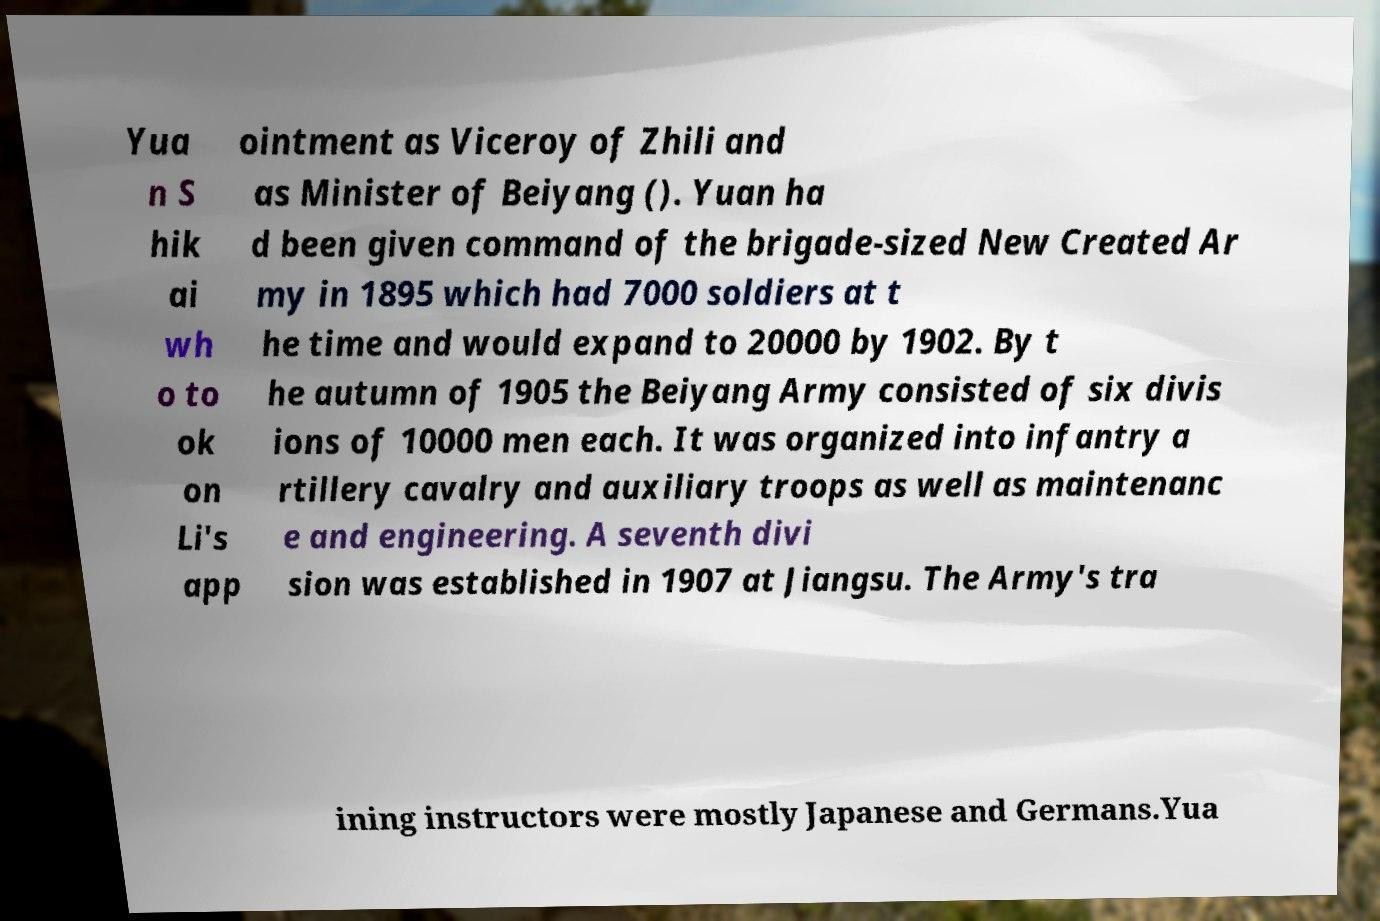Please read and relay the text visible in this image. What does it say? Yua n S hik ai wh o to ok on Li's app ointment as Viceroy of Zhili and as Minister of Beiyang (). Yuan ha d been given command of the brigade-sized New Created Ar my in 1895 which had 7000 soldiers at t he time and would expand to 20000 by 1902. By t he autumn of 1905 the Beiyang Army consisted of six divis ions of 10000 men each. It was organized into infantry a rtillery cavalry and auxiliary troops as well as maintenanc e and engineering. A seventh divi sion was established in 1907 at Jiangsu. The Army's tra ining instructors were mostly Japanese and Germans.Yua 